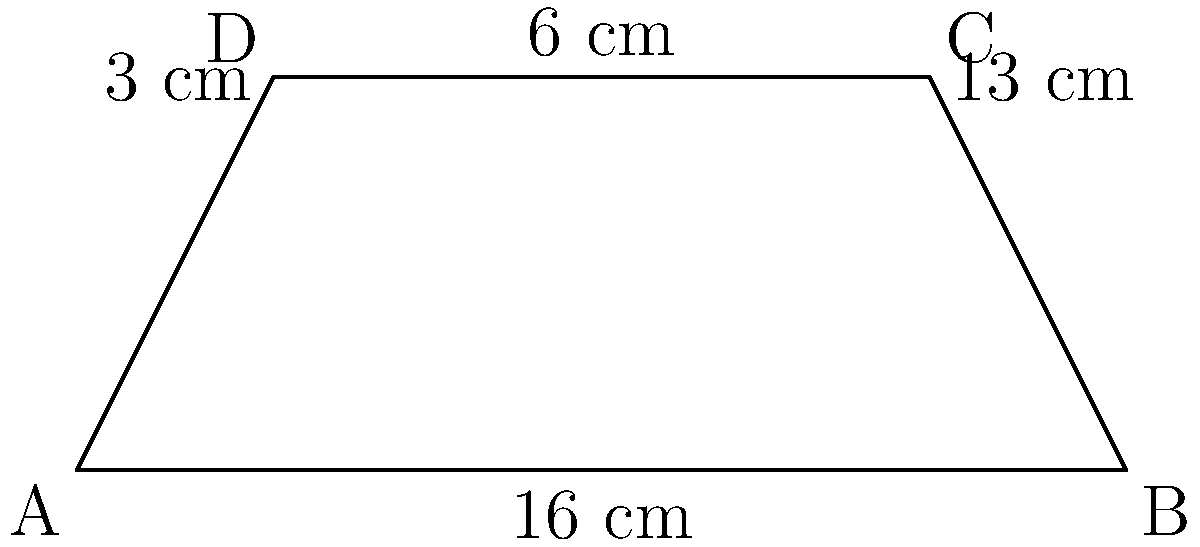In a nod to the widescreen aspect ratio of modern cinema, consider a trapezoid ABCD representing a movie screen. Given that AB = 16 cm, DC = 10 cm, and the height (distance between parallel sides) is 6 cm, calculate the area of this cinematic trapezoid. How does this shape reflect the immersive visual experience that Matt Damon's performances often create? Let's approach this step-by-step, much like analyzing a complex Matt Damon performance:

1) The formula for the area of a trapezoid is:
   $$A = \frac{1}{2}(b_1 + b_2)h$$
   where $b_1$ and $b_2$ are the lengths of the parallel sides, and $h$ is the height.

2) We're given:
   - $b_1 = AB = 16$ cm (the longer base)
   - $h = 6$ cm (the height)
   - $DC = 10$ cm (the shorter base)

3) Calculate the area:
   $$A = \frac{1}{2}(16 + 10) \times 6$$
   $$A = \frac{1}{2}(26) \times 6$$
   $$A = 13 \times 6$$
   $$A = 78 \text{ cm}^2$$

4) The trapezoid shape mimics the widescreen aspect ratio used in many modern films. This wider format allows for a more immersive viewing experience, much like how Matt Damon's versatile performances draw viewers into diverse storylines and characters.
Answer: 78 cm² 